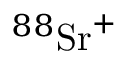<formula> <loc_0><loc_0><loc_500><loc_500>{ } ^ { 8 8 } S r ^ { + }</formula> 